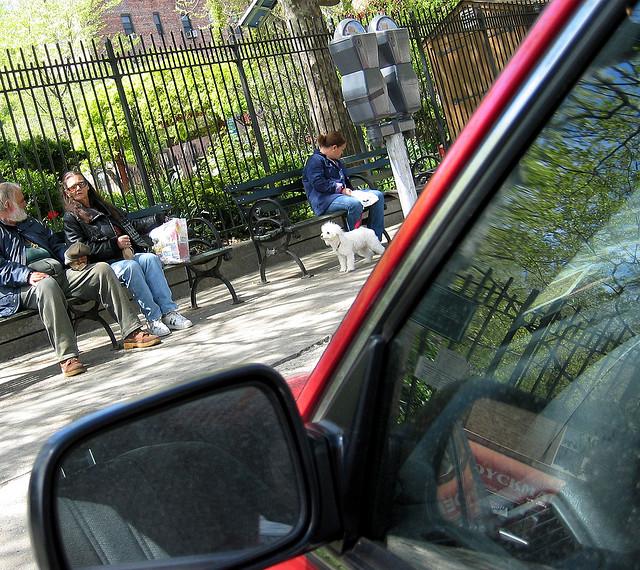What color is the dog?
Be succinct. White. Is the dog sleeping?
Answer briefly. No. What color is the man's beard?
Be succinct. White. 